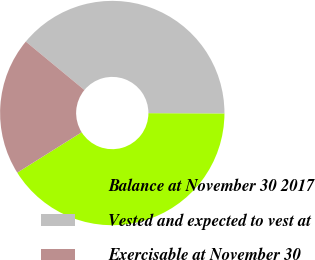<chart> <loc_0><loc_0><loc_500><loc_500><pie_chart><fcel>Balance at November 30 2017<fcel>Vested and expected to vest at<fcel>Exercisable at November 30<nl><fcel>41.03%<fcel>39.06%<fcel>19.91%<nl></chart> 